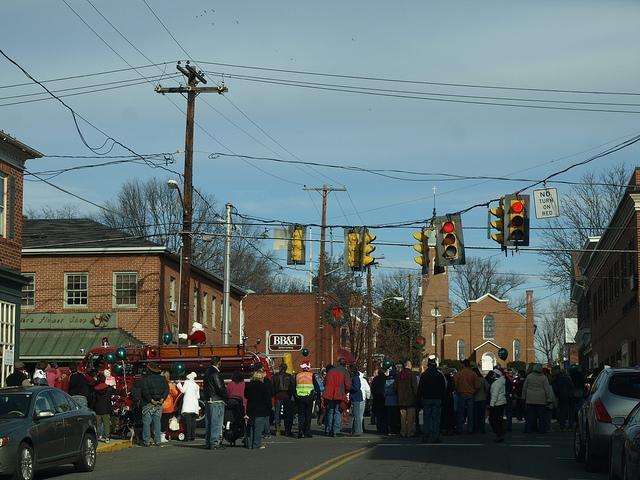Why are people in the middle of the street?
Indicate the correct response and explain using: 'Answer: answer
Rationale: rationale.'
Options: Parade passing, marathon, mass protest, fire sale. Answer: parade passing.
Rationale: There's a parade going. 